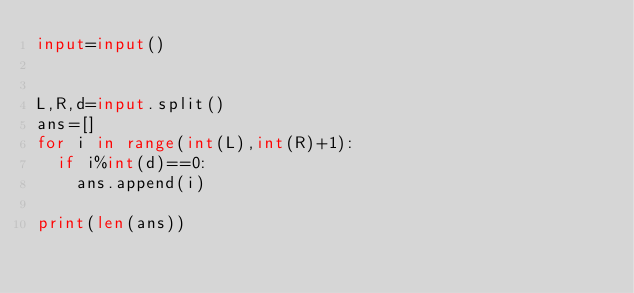Convert code to text. <code><loc_0><loc_0><loc_500><loc_500><_Python_>input=input()


L,R,d=input.split()
ans=[]
for i in range(int(L),int(R)+1):
  if i%int(d)==0:
    ans.append(i)

print(len(ans))
</code> 